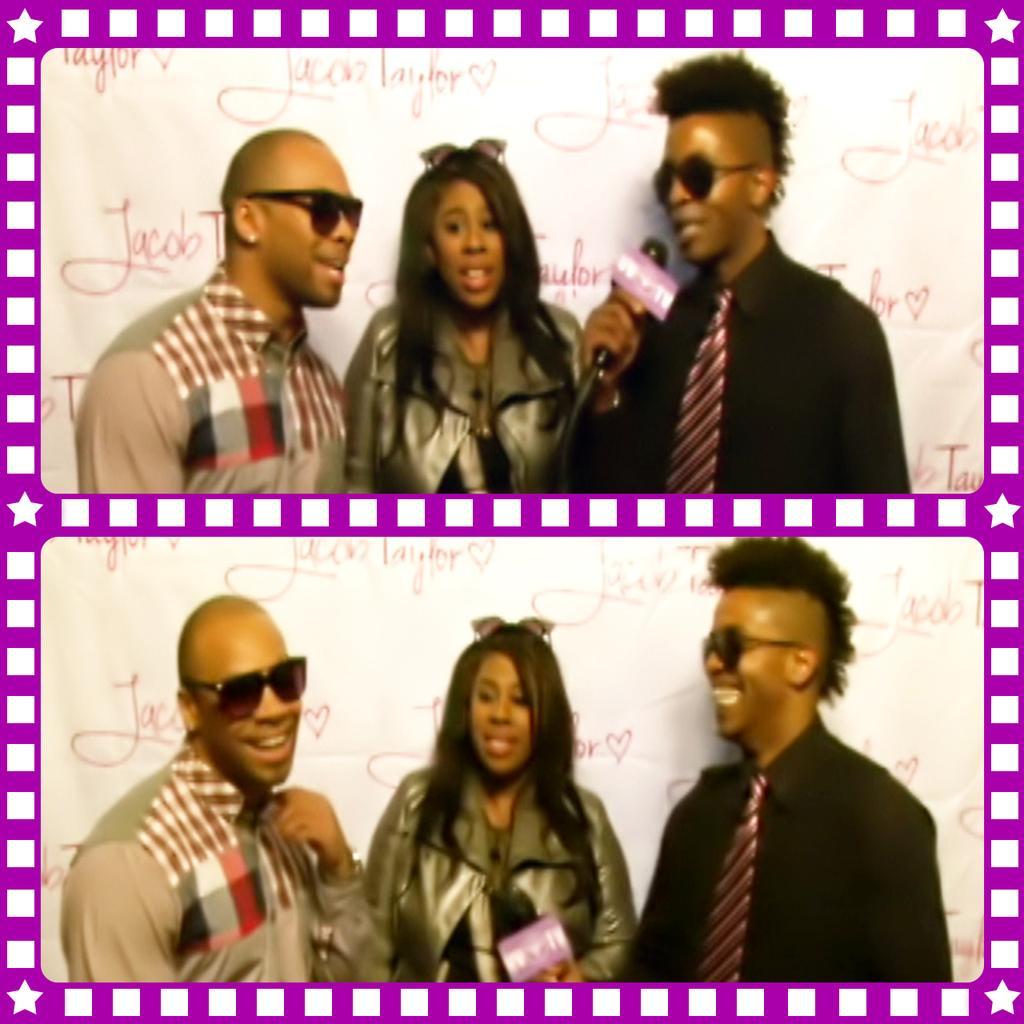Could you give a brief overview of what you see in this image? This is a collage image, in this image there are two picture, in two pictures there are two men an a women. 